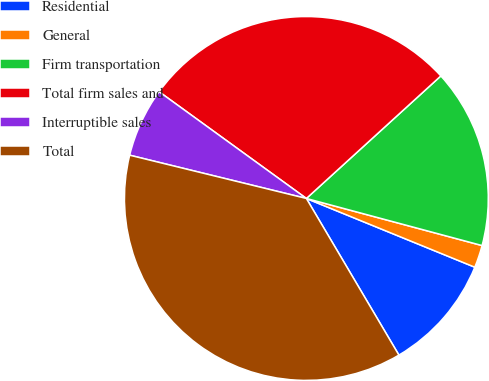Convert chart. <chart><loc_0><loc_0><loc_500><loc_500><pie_chart><fcel>Residential<fcel>General<fcel>Firm transportation<fcel>Total firm sales and<fcel>Interruptible sales<fcel>Total<nl><fcel>10.34%<fcel>2.0%<fcel>15.93%<fcel>28.26%<fcel>6.16%<fcel>37.32%<nl></chart> 